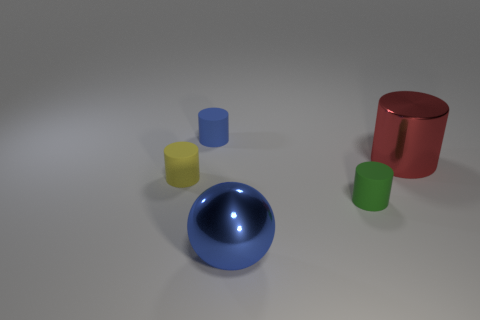Add 2 blue matte cylinders. How many objects exist? 7 Subtract all balls. How many objects are left? 4 Add 5 small spheres. How many small spheres exist? 5 Subtract 0 cyan cylinders. How many objects are left? 5 Subtract all small blue matte cylinders. Subtract all blue spheres. How many objects are left? 3 Add 1 tiny yellow cylinders. How many tiny yellow cylinders are left? 2 